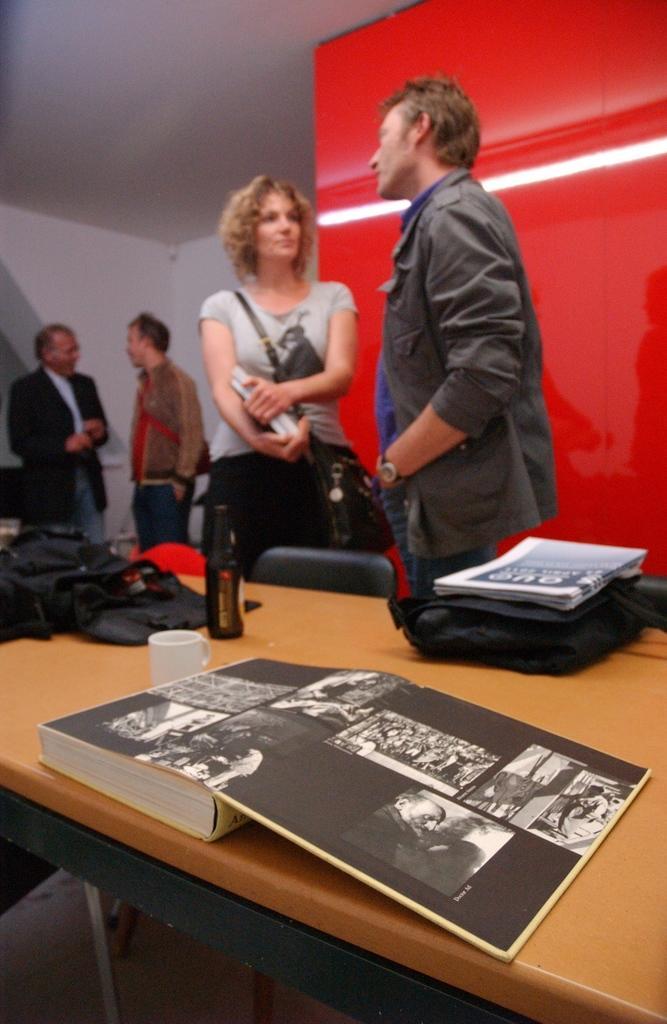Please provide a concise description of this image. A man and woman are talking to each other. There are two men at a distance talking to each other behind them. 